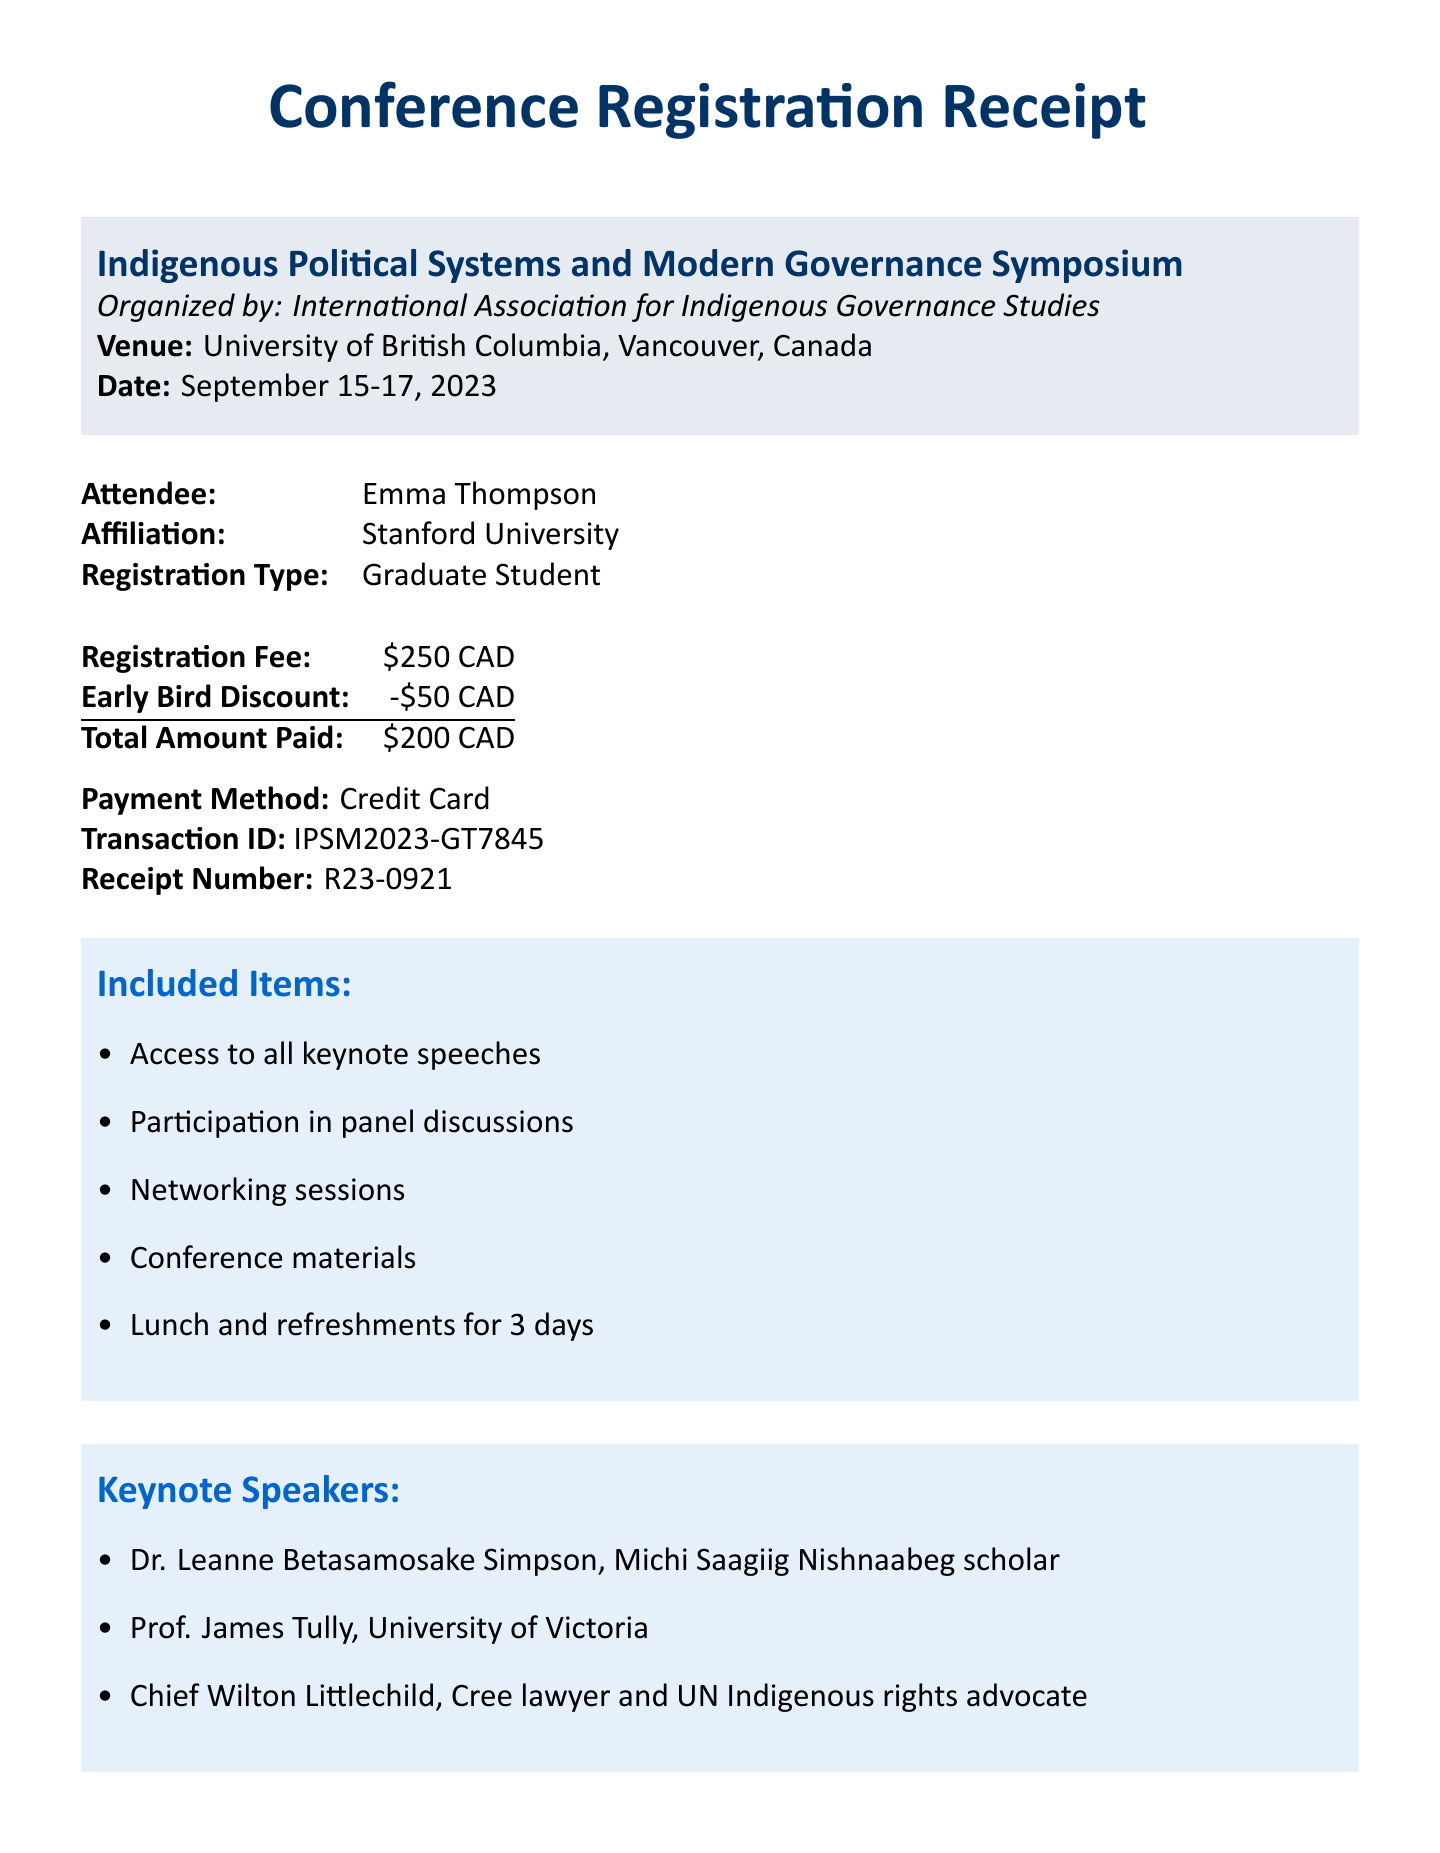What is the venue for the symposium? The venue is specified as the University of British Columbia, Vancouver, Canada.
Answer: University of British Columbia, Vancouver, Canada What is the registration fee? The registration fee is clearly listed in the document.
Answer: $250 CAD Who is the attendee? The document specifies the name of the attendee.
Answer: Emma Thompson What is the total amount paid after the early bird discount? The total amount is derived from the registration fee after the early bird discount.
Answer: $200 CAD What is the cancellation policy? The cancellation policy states the terms regarding refunds and timelines for cancellation.
Answer: 50% refund if cancelled before August 15, 2023. No refunds after this date How many days does the conference last? The date range for the symposium indicates the duration of the event.
Answer: 3 days Which organization organized the symposium? The document states the organizing body of the symposium.
Answer: International Association for Indigenous Governance Studies What is required for attendance regarding COVID-19? The document outlines specific COVID-19 attendance requirements.
Answer: Proof of vaccination or negative PCR test required for attendance 